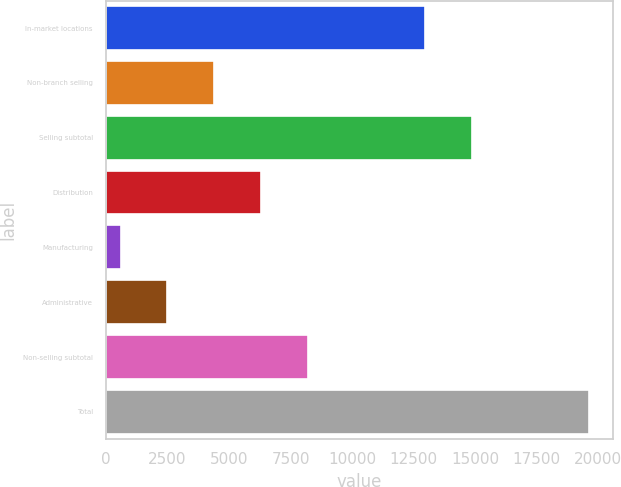<chart> <loc_0><loc_0><loc_500><loc_500><bar_chart><fcel>In-market locations<fcel>Non-branch selling<fcel>Selling subtotal<fcel>Distribution<fcel>Manufacturing<fcel>Administrative<fcel>Non-selling subtotal<fcel>Total<nl><fcel>12966<fcel>4400<fcel>14869<fcel>6303<fcel>594<fcel>2497<fcel>8206<fcel>19624<nl></chart> 